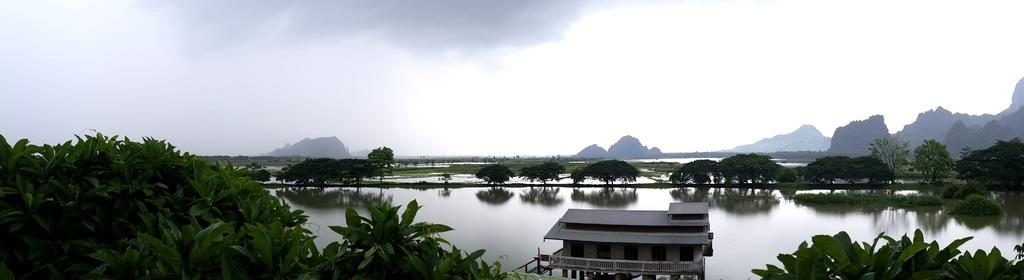What type of structure is located in the center of the image? There is a house on the water in the center of the image. What type of vegetation can be seen in the image? There are trees in the image. What type of natural feature is visible in the background of the image? There are mountains in the background of the image. What is visible in the sky at the top of the image? There are clouds in the sky at the top of the image. How many horses are visible in the image? There are no horses present in the image. What type of cough medicine is recommended for the coughing person in the image? There is no person coughing in the image, so it is not possible to recommend any cough medicine. 